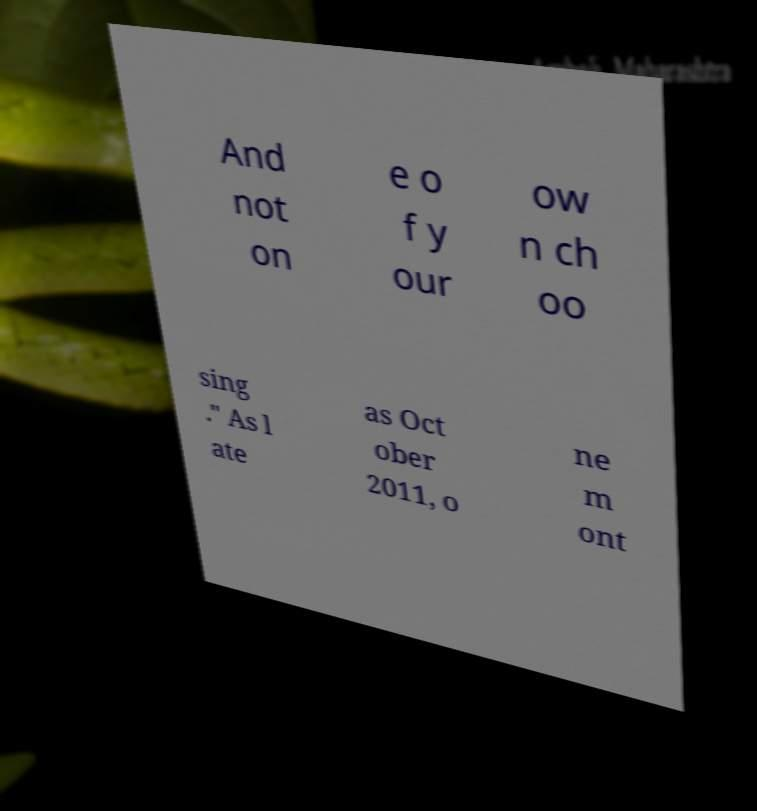For documentation purposes, I need the text within this image transcribed. Could you provide that? And not on e o f y our ow n ch oo sing ." As l ate as Oct ober 2011, o ne m ont 